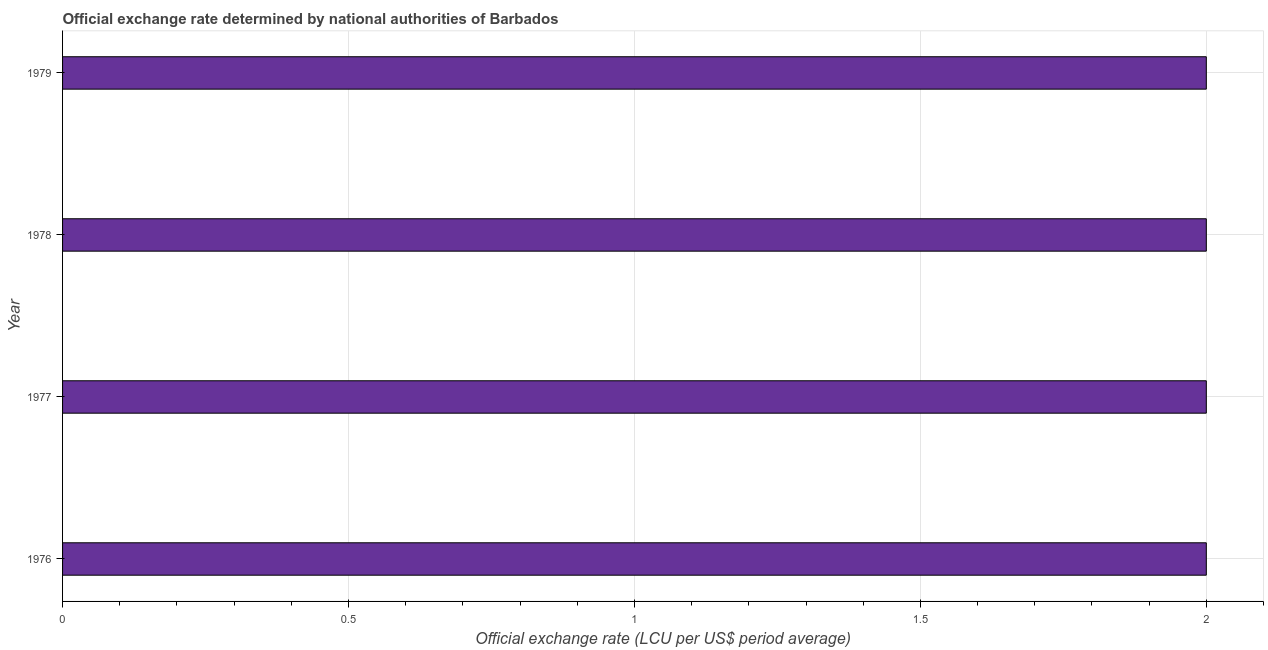What is the title of the graph?
Your answer should be compact. Official exchange rate determined by national authorities of Barbados. What is the label or title of the X-axis?
Keep it short and to the point. Official exchange rate (LCU per US$ period average). What is the label or title of the Y-axis?
Ensure brevity in your answer.  Year. In which year was the official exchange rate maximum?
Your response must be concise. 1976. In which year was the official exchange rate minimum?
Your answer should be compact. 1976. What is the difference between the official exchange rate in 1976 and 1979?
Your response must be concise. 0. What is the average official exchange rate per year?
Offer a terse response. 2. What is the median official exchange rate?
Give a very brief answer. 2. Is the sum of the official exchange rate in 1978 and 1979 greater than the maximum official exchange rate across all years?
Make the answer very short. Yes. What is the difference between the highest and the lowest official exchange rate?
Provide a short and direct response. 0. In how many years, is the official exchange rate greater than the average official exchange rate taken over all years?
Your response must be concise. 0. How many bars are there?
Provide a short and direct response. 4. How many years are there in the graph?
Offer a very short reply. 4. What is the difference between two consecutive major ticks on the X-axis?
Your response must be concise. 0.5. Are the values on the major ticks of X-axis written in scientific E-notation?
Make the answer very short. No. What is the Official exchange rate (LCU per US$ period average) of 1977?
Your answer should be compact. 2. What is the Official exchange rate (LCU per US$ period average) of 1978?
Offer a very short reply. 2. What is the difference between the Official exchange rate (LCU per US$ period average) in 1976 and 1977?
Your answer should be very brief. 0. What is the difference between the Official exchange rate (LCU per US$ period average) in 1976 and 1978?
Provide a short and direct response. 0. What is the difference between the Official exchange rate (LCU per US$ period average) in 1976 and 1979?
Keep it short and to the point. 0. What is the ratio of the Official exchange rate (LCU per US$ period average) in 1976 to that in 1978?
Provide a short and direct response. 1. What is the ratio of the Official exchange rate (LCU per US$ period average) in 1977 to that in 1979?
Offer a terse response. 1. 